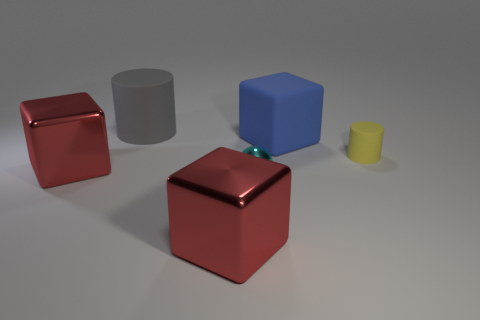What number of rubber cylinders have the same size as the cyan metallic sphere?
Provide a short and direct response. 1. What material is the ball?
Keep it short and to the point. Metal. There is a small cylinder; does it have the same color as the large metal block in front of the cyan thing?
Keep it short and to the point. No. Is there anything else that is the same size as the blue rubber object?
Ensure brevity in your answer.  Yes. There is a block that is on the left side of the tiny metallic object and behind the small shiny thing; what size is it?
Your answer should be compact. Large. What shape is the gray thing that is made of the same material as the small yellow cylinder?
Provide a succinct answer. Cylinder. Is the material of the blue thing the same as the red block that is on the left side of the large gray cylinder?
Offer a terse response. No. Are there any large shiny things that are left of the cylinder that is left of the cyan thing?
Keep it short and to the point. Yes. There is a big gray object that is the same shape as the tiny yellow thing; what is its material?
Make the answer very short. Rubber. There is a big block that is right of the metal sphere; what number of blocks are behind it?
Provide a succinct answer. 0. 